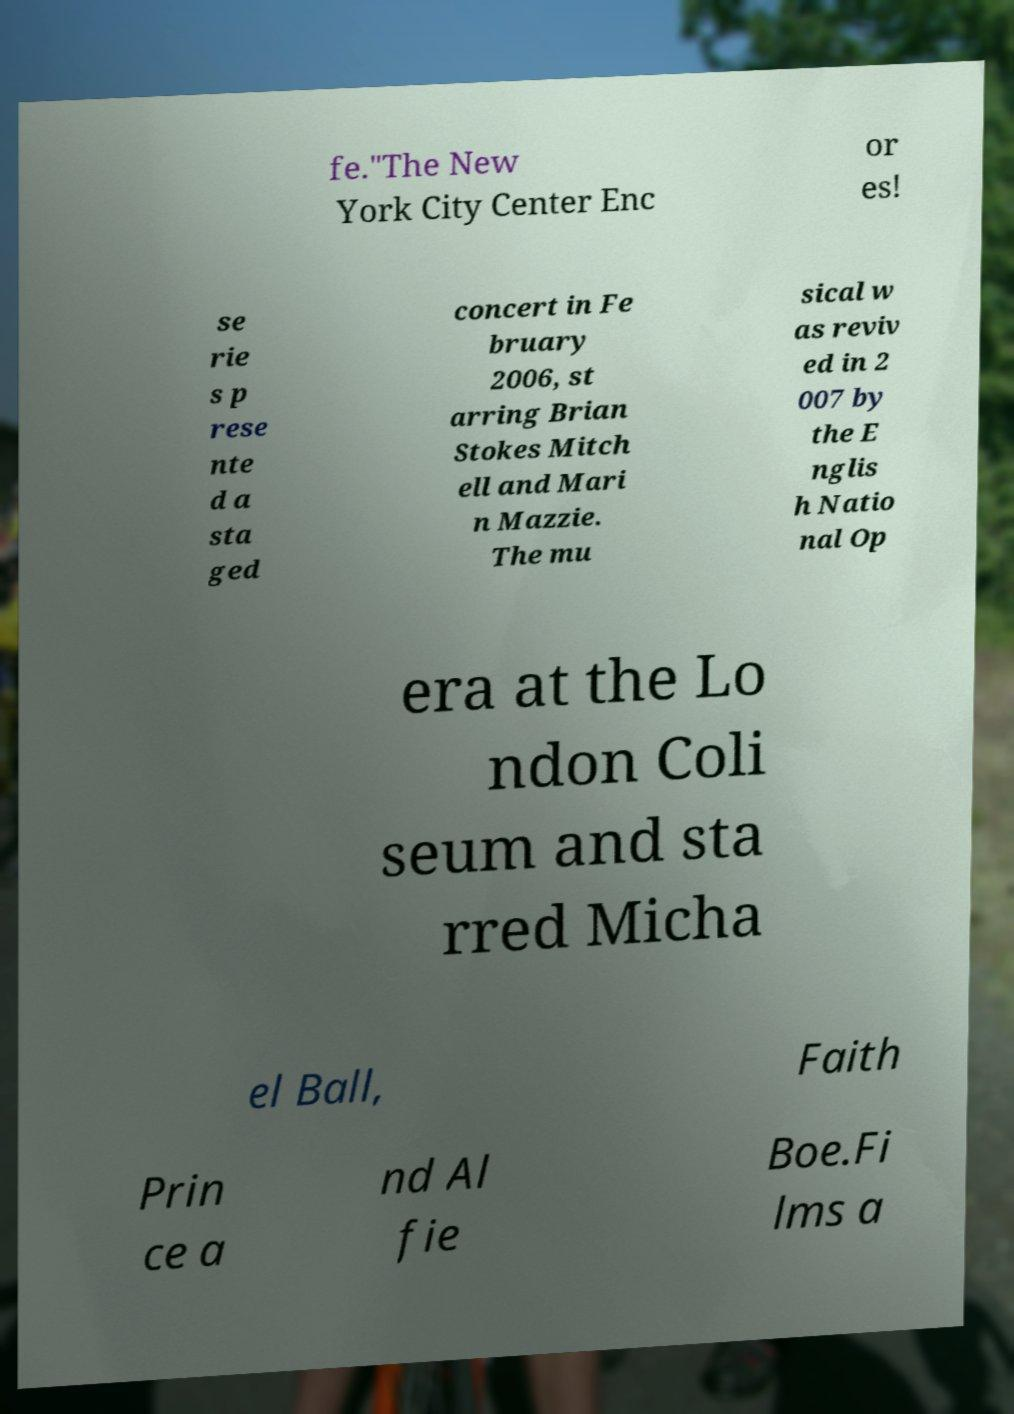Can you accurately transcribe the text from the provided image for me? fe."The New York City Center Enc or es! se rie s p rese nte d a sta ged concert in Fe bruary 2006, st arring Brian Stokes Mitch ell and Mari n Mazzie. The mu sical w as reviv ed in 2 007 by the E nglis h Natio nal Op era at the Lo ndon Coli seum and sta rred Micha el Ball, Faith Prin ce a nd Al fie Boe.Fi lms a 